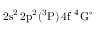Convert formula to latex. <formula><loc_0><loc_0><loc_500><loc_500>2 s ^ { 2 } \, 2 p ^ { 2 } ( ^ { 3 } P ) \, 4 f ^ { 4 } G ^ { \circ }</formula> 